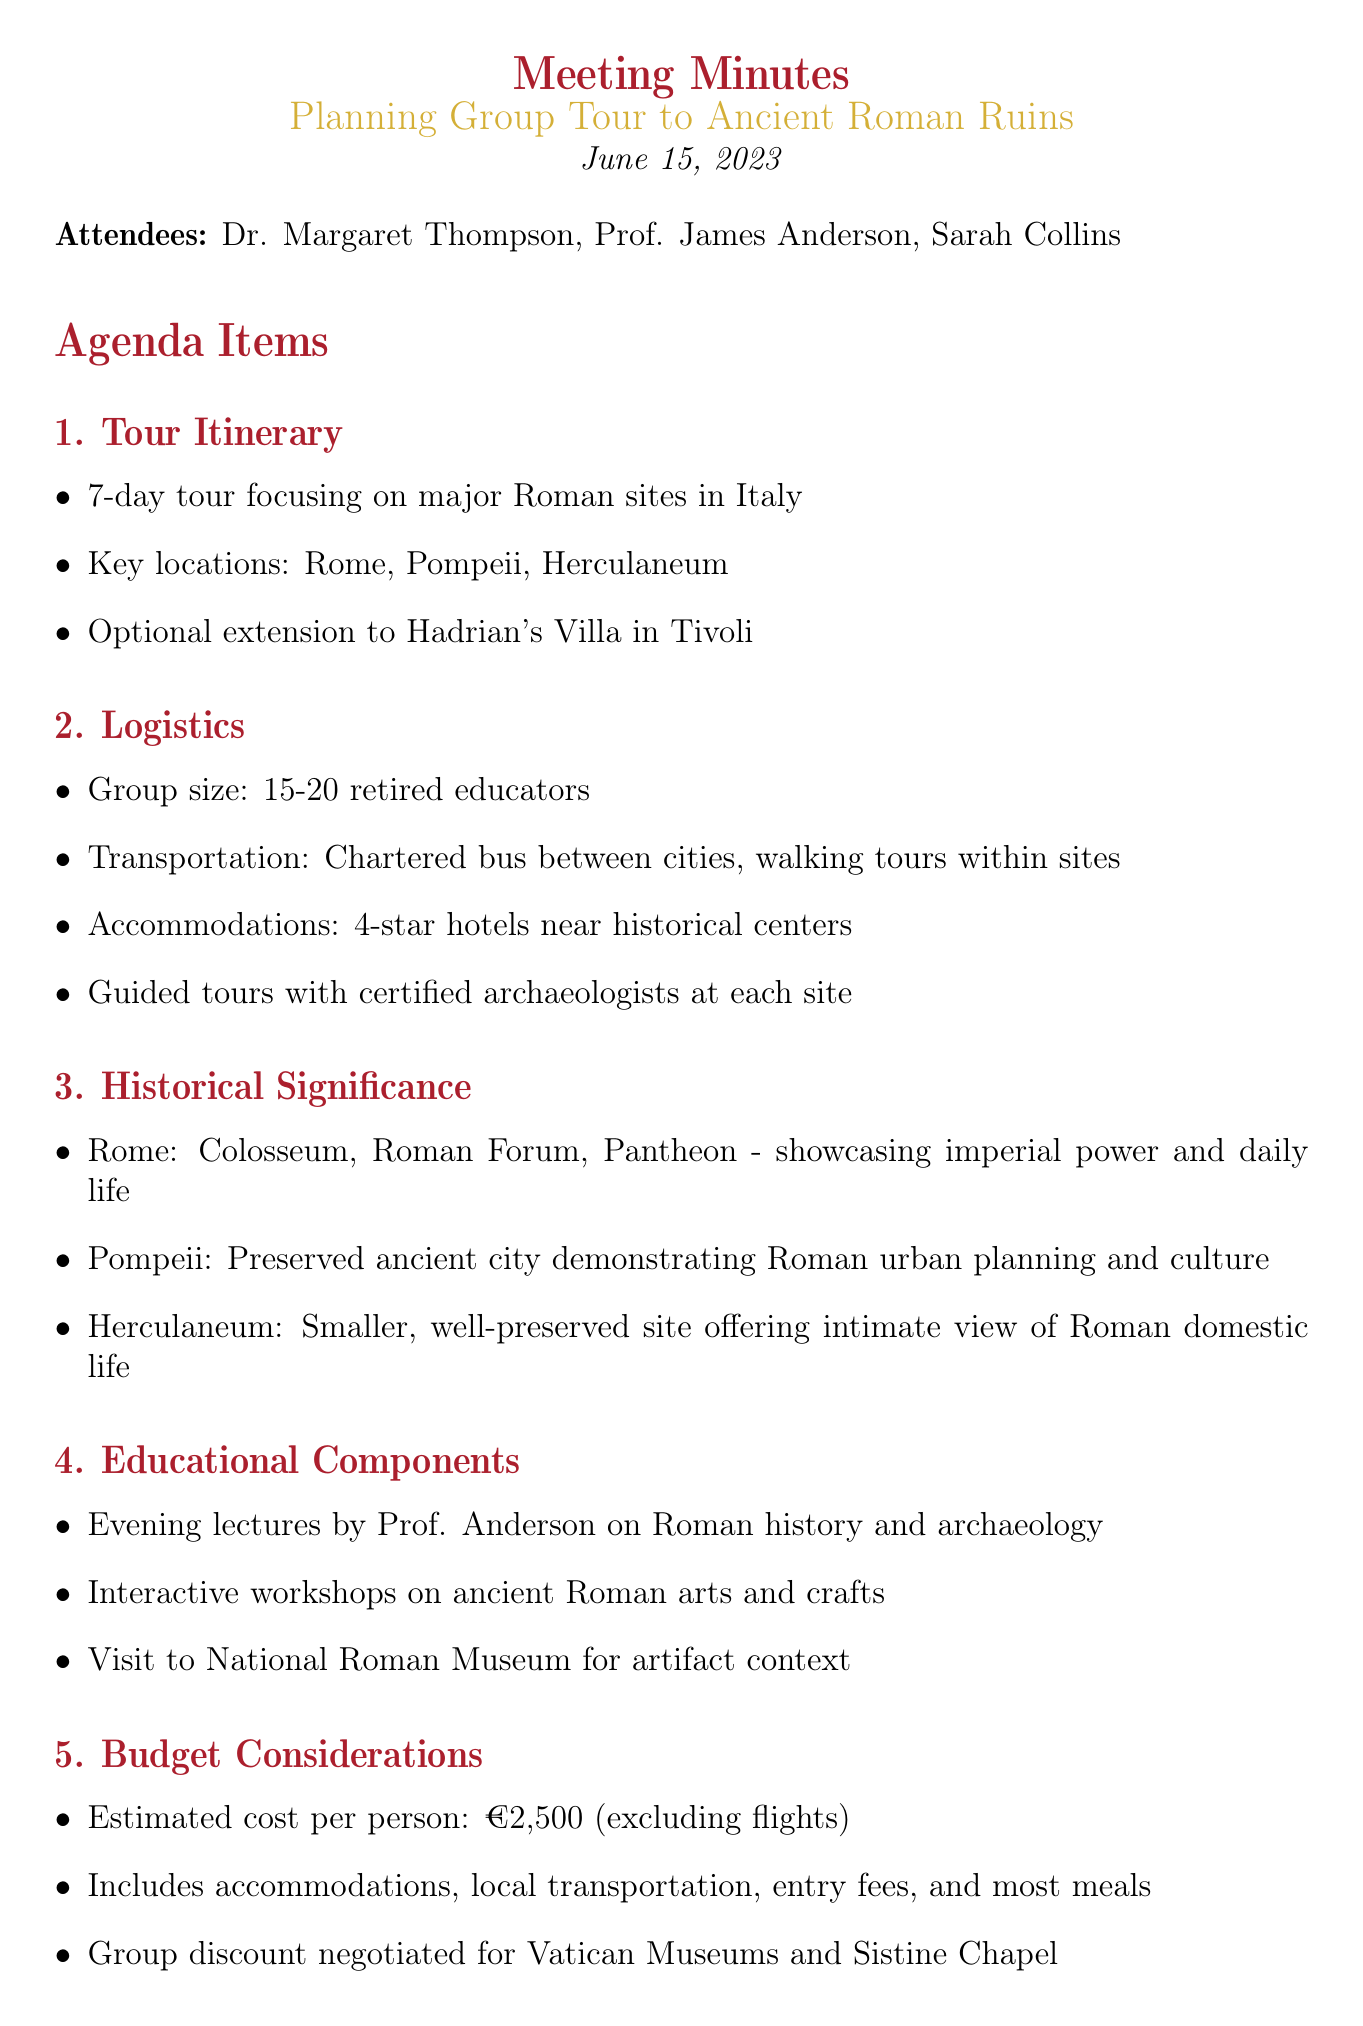What is the date of the meeting? The date of the meeting is specifically mentioned in the document as June 15, 2023.
Answer: June 15, 2023 How many key locations are mentioned for the tour? The document lists a total of three key locations for the tour: Rome, Pompeii, and Herculaneum.
Answer: 3 What is the estimated cost per person for the tour? The document provides the estimated cost per person for the tour, which is stated to be €2,500.
Answer: €2,500 Who is responsible for preparing the pre-trip reading list? The document specifies that Dr. Thompson is tasked with preparing the pre-trip reading list for participants.
Answer: Dr. Thompson What is a historical significance of Pompeii mentioned in the meeting? The document notes that Pompeii is a preserved ancient city demonstrating Roman urban planning and culture.
Answer: Preserved ancient city demonstrating Roman urban planning and culture What type of transportation will be used between cities? The document states that a chartered bus will be utilized for transportation between cities.
Answer: Chartered bus What type of accommodations is planned for the group? The document mentions that accommodations for the group will be in 4-star hotels near historical centers.
Answer: 4-star hotels How many attendees are expected for the group tour? The document indicates that the expected group size is between 15 to 20 retired educators.
Answer: 15-20 What specific educational component involves the National Roman Museum? The document describes a visit to the National Roman Museum as part of the educational components planned for the tour.
Answer: Visit to National Roman Museum 